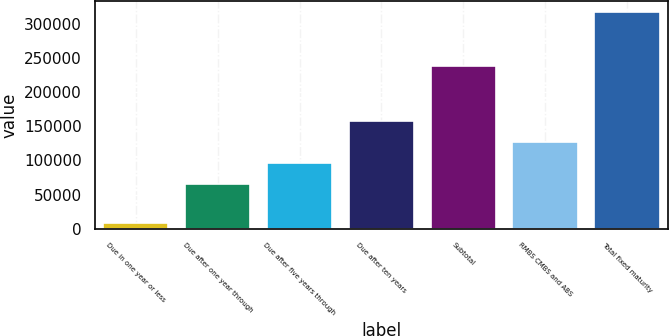Convert chart. <chart><loc_0><loc_0><loc_500><loc_500><bar_chart><fcel>Due in one year or less<fcel>Due after one year through<fcel>Due after five years through<fcel>Due after ten years<fcel>Subtotal<fcel>RMBS CMBS and ABS<fcel>Total fixed maturity<nl><fcel>8580<fcel>65143<fcel>96046.7<fcel>157854<fcel>238214<fcel>126950<fcel>317617<nl></chart> 